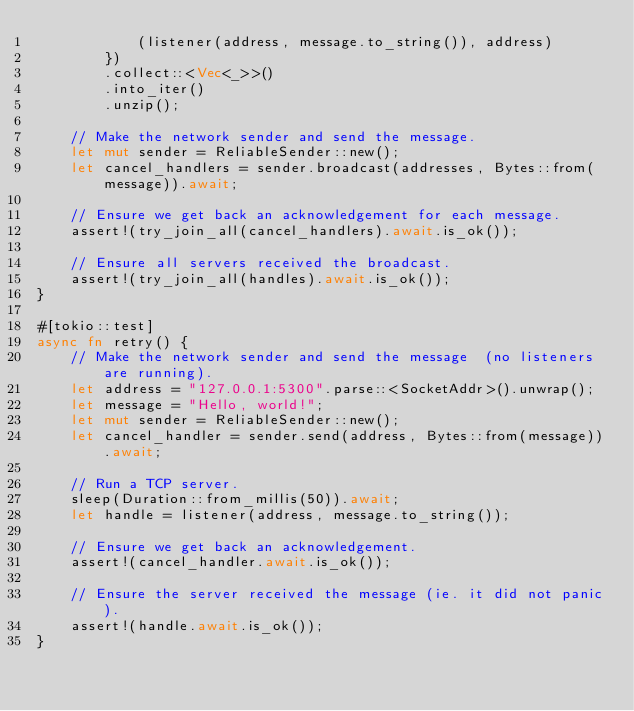<code> <loc_0><loc_0><loc_500><loc_500><_Rust_>            (listener(address, message.to_string()), address)
        })
        .collect::<Vec<_>>()
        .into_iter()
        .unzip();

    // Make the network sender and send the message.
    let mut sender = ReliableSender::new();
    let cancel_handlers = sender.broadcast(addresses, Bytes::from(message)).await;

    // Ensure we get back an acknowledgement for each message.
    assert!(try_join_all(cancel_handlers).await.is_ok());

    // Ensure all servers received the broadcast.
    assert!(try_join_all(handles).await.is_ok());
}

#[tokio::test]
async fn retry() {
    // Make the network sender and send the message  (no listeners are running).
    let address = "127.0.0.1:5300".parse::<SocketAddr>().unwrap();
    let message = "Hello, world!";
    let mut sender = ReliableSender::new();
    let cancel_handler = sender.send(address, Bytes::from(message)).await;

    // Run a TCP server.
    sleep(Duration::from_millis(50)).await;
    let handle = listener(address, message.to_string());

    // Ensure we get back an acknowledgement.
    assert!(cancel_handler.await.is_ok());

    // Ensure the server received the message (ie. it did not panic).
    assert!(handle.await.is_ok());
}
</code> 